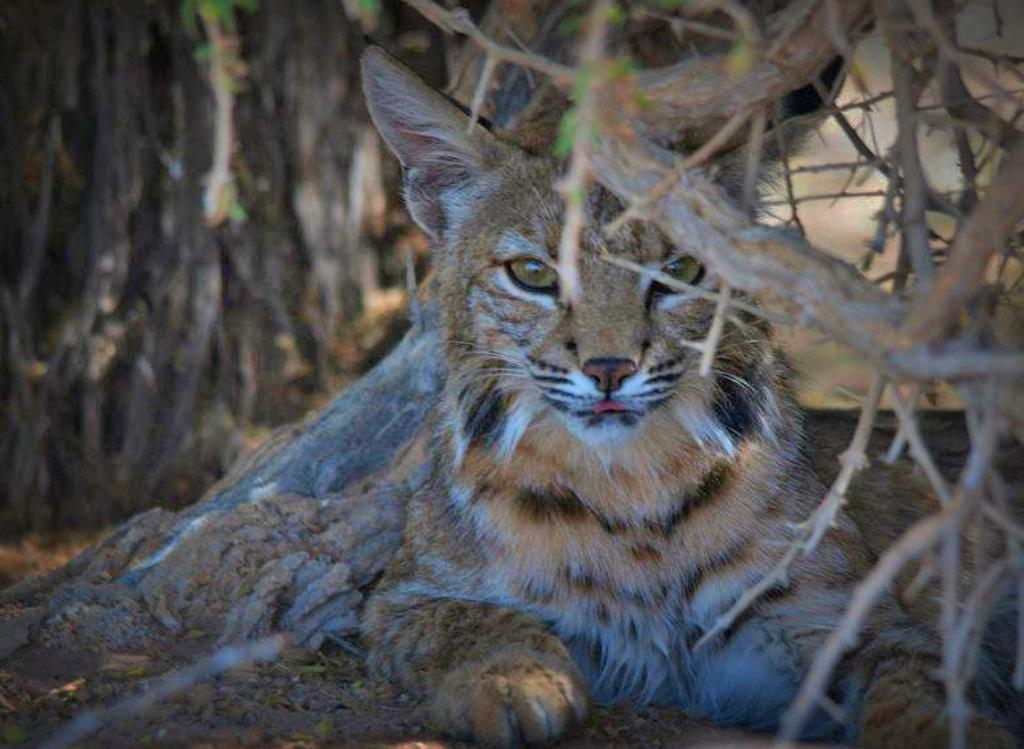What type of animal is in the image? There is a bobcat in the image. What else can be seen in the image besides the bobcat? There are stems visible in the image. What type of whip is being used by the bobcat in the image? There is no whip present in the image, and the bobcat is not using any whip. What type of print can be seen on the stems in the image? There is no print visible on the stems in the image. What type of metal is the bobcat made of in the image? The bobcat is a living animal and not made of any metal, including zinc. 